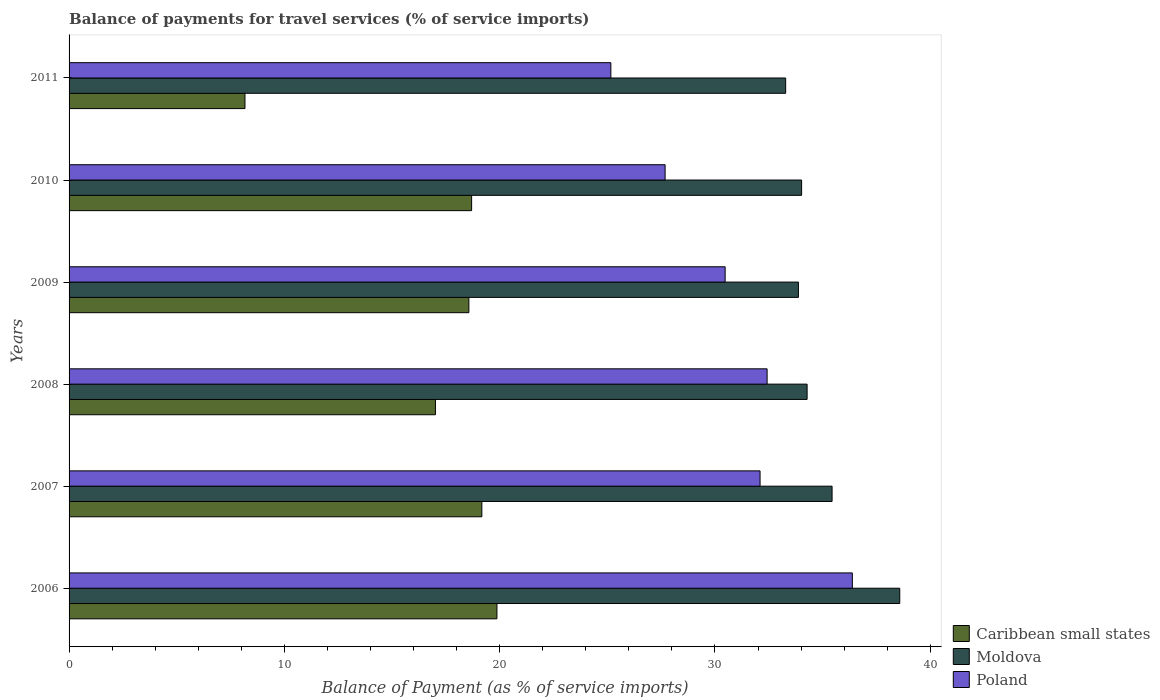How many different coloured bars are there?
Your answer should be compact. 3. How many groups of bars are there?
Offer a very short reply. 6. Are the number of bars per tick equal to the number of legend labels?
Keep it short and to the point. Yes. What is the balance of payments for travel services in Caribbean small states in 2006?
Your response must be concise. 19.87. Across all years, what is the maximum balance of payments for travel services in Caribbean small states?
Provide a succinct answer. 19.87. Across all years, what is the minimum balance of payments for travel services in Moldova?
Give a very brief answer. 33.28. In which year was the balance of payments for travel services in Poland maximum?
Your answer should be very brief. 2006. What is the total balance of payments for travel services in Moldova in the graph?
Give a very brief answer. 209.49. What is the difference between the balance of payments for travel services in Caribbean small states in 2007 and that in 2011?
Ensure brevity in your answer.  11. What is the difference between the balance of payments for travel services in Poland in 2010 and the balance of payments for travel services in Moldova in 2009?
Ensure brevity in your answer.  -6.19. What is the average balance of payments for travel services in Caribbean small states per year?
Provide a short and direct response. 16.92. In the year 2008, what is the difference between the balance of payments for travel services in Poland and balance of payments for travel services in Caribbean small states?
Your answer should be very brief. 15.41. In how many years, is the balance of payments for travel services in Caribbean small states greater than 18 %?
Keep it short and to the point. 4. What is the ratio of the balance of payments for travel services in Caribbean small states in 2006 to that in 2010?
Keep it short and to the point. 1.06. Is the balance of payments for travel services in Moldova in 2008 less than that in 2010?
Your response must be concise. No. Is the difference between the balance of payments for travel services in Poland in 2009 and 2011 greater than the difference between the balance of payments for travel services in Caribbean small states in 2009 and 2011?
Make the answer very short. No. What is the difference between the highest and the second highest balance of payments for travel services in Moldova?
Keep it short and to the point. 3.14. What is the difference between the highest and the lowest balance of payments for travel services in Poland?
Ensure brevity in your answer.  11.22. In how many years, is the balance of payments for travel services in Moldova greater than the average balance of payments for travel services in Moldova taken over all years?
Your answer should be compact. 2. Is the sum of the balance of payments for travel services in Moldova in 2008 and 2010 greater than the maximum balance of payments for travel services in Caribbean small states across all years?
Keep it short and to the point. Yes. What does the 1st bar from the top in 2010 represents?
Offer a very short reply. Poland. What does the 1st bar from the bottom in 2009 represents?
Give a very brief answer. Caribbean small states. How many bars are there?
Ensure brevity in your answer.  18. Are all the bars in the graph horizontal?
Provide a succinct answer. Yes. How many years are there in the graph?
Offer a very short reply. 6. What is the difference between two consecutive major ticks on the X-axis?
Your response must be concise. 10. Does the graph contain grids?
Make the answer very short. No. Where does the legend appear in the graph?
Provide a succinct answer. Bottom right. How many legend labels are there?
Provide a succinct answer. 3. How are the legend labels stacked?
Give a very brief answer. Vertical. What is the title of the graph?
Provide a short and direct response. Balance of payments for travel services (% of service imports). Does "Lithuania" appear as one of the legend labels in the graph?
Your answer should be very brief. No. What is the label or title of the X-axis?
Your response must be concise. Balance of Payment (as % of service imports). What is the Balance of Payment (as % of service imports) in Caribbean small states in 2006?
Provide a succinct answer. 19.87. What is the Balance of Payment (as % of service imports) of Moldova in 2006?
Provide a succinct answer. 38.58. What is the Balance of Payment (as % of service imports) of Poland in 2006?
Your response must be concise. 36.38. What is the Balance of Payment (as % of service imports) in Caribbean small states in 2007?
Make the answer very short. 19.17. What is the Balance of Payment (as % of service imports) of Moldova in 2007?
Offer a very short reply. 35.44. What is the Balance of Payment (as % of service imports) in Poland in 2007?
Offer a terse response. 32.1. What is the Balance of Payment (as % of service imports) in Caribbean small states in 2008?
Your answer should be compact. 17.02. What is the Balance of Payment (as % of service imports) in Moldova in 2008?
Your answer should be compact. 34.28. What is the Balance of Payment (as % of service imports) of Poland in 2008?
Your answer should be compact. 32.42. What is the Balance of Payment (as % of service imports) of Caribbean small states in 2009?
Provide a short and direct response. 18.57. What is the Balance of Payment (as % of service imports) of Moldova in 2009?
Make the answer very short. 33.88. What is the Balance of Payment (as % of service imports) in Poland in 2009?
Offer a terse response. 30.47. What is the Balance of Payment (as % of service imports) in Caribbean small states in 2010?
Ensure brevity in your answer.  18.7. What is the Balance of Payment (as % of service imports) of Moldova in 2010?
Offer a terse response. 34.03. What is the Balance of Payment (as % of service imports) in Poland in 2010?
Your answer should be very brief. 27.69. What is the Balance of Payment (as % of service imports) of Caribbean small states in 2011?
Make the answer very short. 8.17. What is the Balance of Payment (as % of service imports) in Moldova in 2011?
Offer a very short reply. 33.28. What is the Balance of Payment (as % of service imports) in Poland in 2011?
Ensure brevity in your answer.  25.17. Across all years, what is the maximum Balance of Payment (as % of service imports) of Caribbean small states?
Provide a short and direct response. 19.87. Across all years, what is the maximum Balance of Payment (as % of service imports) of Moldova?
Your response must be concise. 38.58. Across all years, what is the maximum Balance of Payment (as % of service imports) of Poland?
Give a very brief answer. 36.38. Across all years, what is the minimum Balance of Payment (as % of service imports) of Caribbean small states?
Provide a short and direct response. 8.17. Across all years, what is the minimum Balance of Payment (as % of service imports) of Moldova?
Give a very brief answer. 33.28. Across all years, what is the minimum Balance of Payment (as % of service imports) in Poland?
Make the answer very short. 25.17. What is the total Balance of Payment (as % of service imports) in Caribbean small states in the graph?
Provide a succinct answer. 101.5. What is the total Balance of Payment (as % of service imports) in Moldova in the graph?
Keep it short and to the point. 209.49. What is the total Balance of Payment (as % of service imports) of Poland in the graph?
Give a very brief answer. 184.23. What is the difference between the Balance of Payment (as % of service imports) of Caribbean small states in 2006 and that in 2007?
Provide a succinct answer. 0.7. What is the difference between the Balance of Payment (as % of service imports) in Moldova in 2006 and that in 2007?
Ensure brevity in your answer.  3.14. What is the difference between the Balance of Payment (as % of service imports) of Poland in 2006 and that in 2007?
Ensure brevity in your answer.  4.29. What is the difference between the Balance of Payment (as % of service imports) of Caribbean small states in 2006 and that in 2008?
Your response must be concise. 2.86. What is the difference between the Balance of Payment (as % of service imports) of Moldova in 2006 and that in 2008?
Your answer should be compact. 4.3. What is the difference between the Balance of Payment (as % of service imports) of Poland in 2006 and that in 2008?
Ensure brevity in your answer.  3.96. What is the difference between the Balance of Payment (as % of service imports) in Caribbean small states in 2006 and that in 2009?
Your answer should be very brief. 1.3. What is the difference between the Balance of Payment (as % of service imports) of Moldova in 2006 and that in 2009?
Your answer should be compact. 4.71. What is the difference between the Balance of Payment (as % of service imports) in Poland in 2006 and that in 2009?
Your answer should be very brief. 5.91. What is the difference between the Balance of Payment (as % of service imports) of Caribbean small states in 2006 and that in 2010?
Make the answer very short. 1.18. What is the difference between the Balance of Payment (as % of service imports) of Moldova in 2006 and that in 2010?
Offer a very short reply. 4.56. What is the difference between the Balance of Payment (as % of service imports) of Poland in 2006 and that in 2010?
Your response must be concise. 8.7. What is the difference between the Balance of Payment (as % of service imports) in Caribbean small states in 2006 and that in 2011?
Offer a terse response. 11.7. What is the difference between the Balance of Payment (as % of service imports) in Moldova in 2006 and that in 2011?
Your response must be concise. 5.3. What is the difference between the Balance of Payment (as % of service imports) of Poland in 2006 and that in 2011?
Give a very brief answer. 11.22. What is the difference between the Balance of Payment (as % of service imports) in Caribbean small states in 2007 and that in 2008?
Offer a terse response. 2.16. What is the difference between the Balance of Payment (as % of service imports) in Moldova in 2007 and that in 2008?
Provide a short and direct response. 1.16. What is the difference between the Balance of Payment (as % of service imports) in Poland in 2007 and that in 2008?
Offer a terse response. -0.33. What is the difference between the Balance of Payment (as % of service imports) of Caribbean small states in 2007 and that in 2009?
Make the answer very short. 0.6. What is the difference between the Balance of Payment (as % of service imports) of Moldova in 2007 and that in 2009?
Your answer should be compact. 1.56. What is the difference between the Balance of Payment (as % of service imports) in Poland in 2007 and that in 2009?
Provide a short and direct response. 1.62. What is the difference between the Balance of Payment (as % of service imports) in Caribbean small states in 2007 and that in 2010?
Make the answer very short. 0.47. What is the difference between the Balance of Payment (as % of service imports) in Moldova in 2007 and that in 2010?
Provide a succinct answer. 1.42. What is the difference between the Balance of Payment (as % of service imports) in Poland in 2007 and that in 2010?
Offer a terse response. 4.41. What is the difference between the Balance of Payment (as % of service imports) of Caribbean small states in 2007 and that in 2011?
Ensure brevity in your answer.  11. What is the difference between the Balance of Payment (as % of service imports) of Moldova in 2007 and that in 2011?
Make the answer very short. 2.16. What is the difference between the Balance of Payment (as % of service imports) in Poland in 2007 and that in 2011?
Your answer should be very brief. 6.93. What is the difference between the Balance of Payment (as % of service imports) in Caribbean small states in 2008 and that in 2009?
Your answer should be compact. -1.55. What is the difference between the Balance of Payment (as % of service imports) of Moldova in 2008 and that in 2009?
Offer a terse response. 0.4. What is the difference between the Balance of Payment (as % of service imports) of Poland in 2008 and that in 2009?
Your answer should be compact. 1.95. What is the difference between the Balance of Payment (as % of service imports) of Caribbean small states in 2008 and that in 2010?
Offer a terse response. -1.68. What is the difference between the Balance of Payment (as % of service imports) in Moldova in 2008 and that in 2010?
Provide a short and direct response. 0.26. What is the difference between the Balance of Payment (as % of service imports) of Poland in 2008 and that in 2010?
Your response must be concise. 4.74. What is the difference between the Balance of Payment (as % of service imports) of Caribbean small states in 2008 and that in 2011?
Provide a succinct answer. 8.85. What is the difference between the Balance of Payment (as % of service imports) in Moldova in 2008 and that in 2011?
Offer a very short reply. 1. What is the difference between the Balance of Payment (as % of service imports) of Poland in 2008 and that in 2011?
Your answer should be very brief. 7.26. What is the difference between the Balance of Payment (as % of service imports) in Caribbean small states in 2009 and that in 2010?
Your answer should be compact. -0.13. What is the difference between the Balance of Payment (as % of service imports) in Moldova in 2009 and that in 2010?
Ensure brevity in your answer.  -0.15. What is the difference between the Balance of Payment (as % of service imports) in Poland in 2009 and that in 2010?
Offer a very short reply. 2.79. What is the difference between the Balance of Payment (as % of service imports) of Caribbean small states in 2009 and that in 2011?
Provide a short and direct response. 10.4. What is the difference between the Balance of Payment (as % of service imports) in Moldova in 2009 and that in 2011?
Provide a short and direct response. 0.59. What is the difference between the Balance of Payment (as % of service imports) of Poland in 2009 and that in 2011?
Make the answer very short. 5.31. What is the difference between the Balance of Payment (as % of service imports) of Caribbean small states in 2010 and that in 2011?
Your response must be concise. 10.53. What is the difference between the Balance of Payment (as % of service imports) of Moldova in 2010 and that in 2011?
Offer a very short reply. 0.74. What is the difference between the Balance of Payment (as % of service imports) in Poland in 2010 and that in 2011?
Offer a very short reply. 2.52. What is the difference between the Balance of Payment (as % of service imports) of Caribbean small states in 2006 and the Balance of Payment (as % of service imports) of Moldova in 2007?
Your answer should be very brief. -15.57. What is the difference between the Balance of Payment (as % of service imports) of Caribbean small states in 2006 and the Balance of Payment (as % of service imports) of Poland in 2007?
Ensure brevity in your answer.  -12.22. What is the difference between the Balance of Payment (as % of service imports) of Moldova in 2006 and the Balance of Payment (as % of service imports) of Poland in 2007?
Provide a succinct answer. 6.49. What is the difference between the Balance of Payment (as % of service imports) of Caribbean small states in 2006 and the Balance of Payment (as % of service imports) of Moldova in 2008?
Offer a very short reply. -14.41. What is the difference between the Balance of Payment (as % of service imports) of Caribbean small states in 2006 and the Balance of Payment (as % of service imports) of Poland in 2008?
Offer a terse response. -12.55. What is the difference between the Balance of Payment (as % of service imports) of Moldova in 2006 and the Balance of Payment (as % of service imports) of Poland in 2008?
Your response must be concise. 6.16. What is the difference between the Balance of Payment (as % of service imports) of Caribbean small states in 2006 and the Balance of Payment (as % of service imports) of Moldova in 2009?
Keep it short and to the point. -14. What is the difference between the Balance of Payment (as % of service imports) in Caribbean small states in 2006 and the Balance of Payment (as % of service imports) in Poland in 2009?
Ensure brevity in your answer.  -10.6. What is the difference between the Balance of Payment (as % of service imports) in Moldova in 2006 and the Balance of Payment (as % of service imports) in Poland in 2009?
Offer a very short reply. 8.11. What is the difference between the Balance of Payment (as % of service imports) of Caribbean small states in 2006 and the Balance of Payment (as % of service imports) of Moldova in 2010?
Your answer should be compact. -14.15. What is the difference between the Balance of Payment (as % of service imports) of Caribbean small states in 2006 and the Balance of Payment (as % of service imports) of Poland in 2010?
Provide a short and direct response. -7.81. What is the difference between the Balance of Payment (as % of service imports) in Moldova in 2006 and the Balance of Payment (as % of service imports) in Poland in 2010?
Your answer should be very brief. 10.9. What is the difference between the Balance of Payment (as % of service imports) in Caribbean small states in 2006 and the Balance of Payment (as % of service imports) in Moldova in 2011?
Your response must be concise. -13.41. What is the difference between the Balance of Payment (as % of service imports) in Caribbean small states in 2006 and the Balance of Payment (as % of service imports) in Poland in 2011?
Provide a succinct answer. -5.29. What is the difference between the Balance of Payment (as % of service imports) in Moldova in 2006 and the Balance of Payment (as % of service imports) in Poland in 2011?
Give a very brief answer. 13.42. What is the difference between the Balance of Payment (as % of service imports) of Caribbean small states in 2007 and the Balance of Payment (as % of service imports) of Moldova in 2008?
Give a very brief answer. -15.11. What is the difference between the Balance of Payment (as % of service imports) of Caribbean small states in 2007 and the Balance of Payment (as % of service imports) of Poland in 2008?
Offer a terse response. -13.25. What is the difference between the Balance of Payment (as % of service imports) in Moldova in 2007 and the Balance of Payment (as % of service imports) in Poland in 2008?
Your answer should be very brief. 3.02. What is the difference between the Balance of Payment (as % of service imports) in Caribbean small states in 2007 and the Balance of Payment (as % of service imports) in Moldova in 2009?
Your answer should be compact. -14.7. What is the difference between the Balance of Payment (as % of service imports) of Caribbean small states in 2007 and the Balance of Payment (as % of service imports) of Poland in 2009?
Provide a succinct answer. -11.3. What is the difference between the Balance of Payment (as % of service imports) in Moldova in 2007 and the Balance of Payment (as % of service imports) in Poland in 2009?
Provide a succinct answer. 4.97. What is the difference between the Balance of Payment (as % of service imports) in Caribbean small states in 2007 and the Balance of Payment (as % of service imports) in Moldova in 2010?
Offer a very short reply. -14.85. What is the difference between the Balance of Payment (as % of service imports) in Caribbean small states in 2007 and the Balance of Payment (as % of service imports) in Poland in 2010?
Your answer should be very brief. -8.51. What is the difference between the Balance of Payment (as % of service imports) of Moldova in 2007 and the Balance of Payment (as % of service imports) of Poland in 2010?
Offer a terse response. 7.76. What is the difference between the Balance of Payment (as % of service imports) of Caribbean small states in 2007 and the Balance of Payment (as % of service imports) of Moldova in 2011?
Your answer should be compact. -14.11. What is the difference between the Balance of Payment (as % of service imports) of Caribbean small states in 2007 and the Balance of Payment (as % of service imports) of Poland in 2011?
Your answer should be compact. -5.99. What is the difference between the Balance of Payment (as % of service imports) in Moldova in 2007 and the Balance of Payment (as % of service imports) in Poland in 2011?
Give a very brief answer. 10.27. What is the difference between the Balance of Payment (as % of service imports) in Caribbean small states in 2008 and the Balance of Payment (as % of service imports) in Moldova in 2009?
Give a very brief answer. -16.86. What is the difference between the Balance of Payment (as % of service imports) in Caribbean small states in 2008 and the Balance of Payment (as % of service imports) in Poland in 2009?
Your response must be concise. -13.46. What is the difference between the Balance of Payment (as % of service imports) in Moldova in 2008 and the Balance of Payment (as % of service imports) in Poland in 2009?
Ensure brevity in your answer.  3.81. What is the difference between the Balance of Payment (as % of service imports) of Caribbean small states in 2008 and the Balance of Payment (as % of service imports) of Moldova in 2010?
Keep it short and to the point. -17.01. What is the difference between the Balance of Payment (as % of service imports) in Caribbean small states in 2008 and the Balance of Payment (as % of service imports) in Poland in 2010?
Give a very brief answer. -10.67. What is the difference between the Balance of Payment (as % of service imports) of Moldova in 2008 and the Balance of Payment (as % of service imports) of Poland in 2010?
Your response must be concise. 6.6. What is the difference between the Balance of Payment (as % of service imports) in Caribbean small states in 2008 and the Balance of Payment (as % of service imports) in Moldova in 2011?
Offer a very short reply. -16.27. What is the difference between the Balance of Payment (as % of service imports) of Caribbean small states in 2008 and the Balance of Payment (as % of service imports) of Poland in 2011?
Ensure brevity in your answer.  -8.15. What is the difference between the Balance of Payment (as % of service imports) of Moldova in 2008 and the Balance of Payment (as % of service imports) of Poland in 2011?
Give a very brief answer. 9.12. What is the difference between the Balance of Payment (as % of service imports) of Caribbean small states in 2009 and the Balance of Payment (as % of service imports) of Moldova in 2010?
Provide a short and direct response. -15.46. What is the difference between the Balance of Payment (as % of service imports) of Caribbean small states in 2009 and the Balance of Payment (as % of service imports) of Poland in 2010?
Provide a short and direct response. -9.12. What is the difference between the Balance of Payment (as % of service imports) in Moldova in 2009 and the Balance of Payment (as % of service imports) in Poland in 2010?
Your response must be concise. 6.19. What is the difference between the Balance of Payment (as % of service imports) in Caribbean small states in 2009 and the Balance of Payment (as % of service imports) in Moldova in 2011?
Your answer should be very brief. -14.71. What is the difference between the Balance of Payment (as % of service imports) of Caribbean small states in 2009 and the Balance of Payment (as % of service imports) of Poland in 2011?
Keep it short and to the point. -6.6. What is the difference between the Balance of Payment (as % of service imports) in Moldova in 2009 and the Balance of Payment (as % of service imports) in Poland in 2011?
Offer a terse response. 8.71. What is the difference between the Balance of Payment (as % of service imports) of Caribbean small states in 2010 and the Balance of Payment (as % of service imports) of Moldova in 2011?
Make the answer very short. -14.59. What is the difference between the Balance of Payment (as % of service imports) of Caribbean small states in 2010 and the Balance of Payment (as % of service imports) of Poland in 2011?
Provide a succinct answer. -6.47. What is the difference between the Balance of Payment (as % of service imports) in Moldova in 2010 and the Balance of Payment (as % of service imports) in Poland in 2011?
Offer a terse response. 8.86. What is the average Balance of Payment (as % of service imports) in Caribbean small states per year?
Ensure brevity in your answer.  16.92. What is the average Balance of Payment (as % of service imports) of Moldova per year?
Keep it short and to the point. 34.92. What is the average Balance of Payment (as % of service imports) in Poland per year?
Keep it short and to the point. 30.7. In the year 2006, what is the difference between the Balance of Payment (as % of service imports) in Caribbean small states and Balance of Payment (as % of service imports) in Moldova?
Your response must be concise. -18.71. In the year 2006, what is the difference between the Balance of Payment (as % of service imports) of Caribbean small states and Balance of Payment (as % of service imports) of Poland?
Offer a very short reply. -16.51. In the year 2006, what is the difference between the Balance of Payment (as % of service imports) of Moldova and Balance of Payment (as % of service imports) of Poland?
Keep it short and to the point. 2.2. In the year 2007, what is the difference between the Balance of Payment (as % of service imports) in Caribbean small states and Balance of Payment (as % of service imports) in Moldova?
Offer a very short reply. -16.27. In the year 2007, what is the difference between the Balance of Payment (as % of service imports) in Caribbean small states and Balance of Payment (as % of service imports) in Poland?
Your answer should be very brief. -12.92. In the year 2007, what is the difference between the Balance of Payment (as % of service imports) of Moldova and Balance of Payment (as % of service imports) of Poland?
Your answer should be compact. 3.35. In the year 2008, what is the difference between the Balance of Payment (as % of service imports) in Caribbean small states and Balance of Payment (as % of service imports) in Moldova?
Ensure brevity in your answer.  -17.26. In the year 2008, what is the difference between the Balance of Payment (as % of service imports) of Caribbean small states and Balance of Payment (as % of service imports) of Poland?
Make the answer very short. -15.41. In the year 2008, what is the difference between the Balance of Payment (as % of service imports) in Moldova and Balance of Payment (as % of service imports) in Poland?
Provide a succinct answer. 1.86. In the year 2009, what is the difference between the Balance of Payment (as % of service imports) in Caribbean small states and Balance of Payment (as % of service imports) in Moldova?
Make the answer very short. -15.31. In the year 2009, what is the difference between the Balance of Payment (as % of service imports) in Caribbean small states and Balance of Payment (as % of service imports) in Poland?
Provide a short and direct response. -11.9. In the year 2009, what is the difference between the Balance of Payment (as % of service imports) of Moldova and Balance of Payment (as % of service imports) of Poland?
Keep it short and to the point. 3.4. In the year 2010, what is the difference between the Balance of Payment (as % of service imports) of Caribbean small states and Balance of Payment (as % of service imports) of Moldova?
Give a very brief answer. -15.33. In the year 2010, what is the difference between the Balance of Payment (as % of service imports) in Caribbean small states and Balance of Payment (as % of service imports) in Poland?
Your response must be concise. -8.99. In the year 2010, what is the difference between the Balance of Payment (as % of service imports) of Moldova and Balance of Payment (as % of service imports) of Poland?
Your response must be concise. 6.34. In the year 2011, what is the difference between the Balance of Payment (as % of service imports) of Caribbean small states and Balance of Payment (as % of service imports) of Moldova?
Provide a short and direct response. -25.11. In the year 2011, what is the difference between the Balance of Payment (as % of service imports) of Caribbean small states and Balance of Payment (as % of service imports) of Poland?
Offer a terse response. -17. In the year 2011, what is the difference between the Balance of Payment (as % of service imports) in Moldova and Balance of Payment (as % of service imports) in Poland?
Your response must be concise. 8.12. What is the ratio of the Balance of Payment (as % of service imports) in Caribbean small states in 2006 to that in 2007?
Give a very brief answer. 1.04. What is the ratio of the Balance of Payment (as % of service imports) in Moldova in 2006 to that in 2007?
Your answer should be very brief. 1.09. What is the ratio of the Balance of Payment (as % of service imports) in Poland in 2006 to that in 2007?
Ensure brevity in your answer.  1.13. What is the ratio of the Balance of Payment (as % of service imports) in Caribbean small states in 2006 to that in 2008?
Offer a very short reply. 1.17. What is the ratio of the Balance of Payment (as % of service imports) in Moldova in 2006 to that in 2008?
Offer a terse response. 1.13. What is the ratio of the Balance of Payment (as % of service imports) of Poland in 2006 to that in 2008?
Give a very brief answer. 1.12. What is the ratio of the Balance of Payment (as % of service imports) of Caribbean small states in 2006 to that in 2009?
Provide a succinct answer. 1.07. What is the ratio of the Balance of Payment (as % of service imports) of Moldova in 2006 to that in 2009?
Keep it short and to the point. 1.14. What is the ratio of the Balance of Payment (as % of service imports) in Poland in 2006 to that in 2009?
Your answer should be very brief. 1.19. What is the ratio of the Balance of Payment (as % of service imports) of Caribbean small states in 2006 to that in 2010?
Give a very brief answer. 1.06. What is the ratio of the Balance of Payment (as % of service imports) in Moldova in 2006 to that in 2010?
Your answer should be compact. 1.13. What is the ratio of the Balance of Payment (as % of service imports) in Poland in 2006 to that in 2010?
Make the answer very short. 1.31. What is the ratio of the Balance of Payment (as % of service imports) in Caribbean small states in 2006 to that in 2011?
Your response must be concise. 2.43. What is the ratio of the Balance of Payment (as % of service imports) in Moldova in 2006 to that in 2011?
Offer a very short reply. 1.16. What is the ratio of the Balance of Payment (as % of service imports) in Poland in 2006 to that in 2011?
Your answer should be compact. 1.45. What is the ratio of the Balance of Payment (as % of service imports) in Caribbean small states in 2007 to that in 2008?
Offer a terse response. 1.13. What is the ratio of the Balance of Payment (as % of service imports) of Moldova in 2007 to that in 2008?
Offer a terse response. 1.03. What is the ratio of the Balance of Payment (as % of service imports) of Caribbean small states in 2007 to that in 2009?
Your response must be concise. 1.03. What is the ratio of the Balance of Payment (as % of service imports) of Moldova in 2007 to that in 2009?
Ensure brevity in your answer.  1.05. What is the ratio of the Balance of Payment (as % of service imports) of Poland in 2007 to that in 2009?
Ensure brevity in your answer.  1.05. What is the ratio of the Balance of Payment (as % of service imports) in Caribbean small states in 2007 to that in 2010?
Your response must be concise. 1.03. What is the ratio of the Balance of Payment (as % of service imports) of Moldova in 2007 to that in 2010?
Give a very brief answer. 1.04. What is the ratio of the Balance of Payment (as % of service imports) of Poland in 2007 to that in 2010?
Your response must be concise. 1.16. What is the ratio of the Balance of Payment (as % of service imports) of Caribbean small states in 2007 to that in 2011?
Your response must be concise. 2.35. What is the ratio of the Balance of Payment (as % of service imports) of Moldova in 2007 to that in 2011?
Offer a terse response. 1.06. What is the ratio of the Balance of Payment (as % of service imports) of Poland in 2007 to that in 2011?
Offer a terse response. 1.28. What is the ratio of the Balance of Payment (as % of service imports) of Caribbean small states in 2008 to that in 2009?
Keep it short and to the point. 0.92. What is the ratio of the Balance of Payment (as % of service imports) in Moldova in 2008 to that in 2009?
Your answer should be very brief. 1.01. What is the ratio of the Balance of Payment (as % of service imports) in Poland in 2008 to that in 2009?
Ensure brevity in your answer.  1.06. What is the ratio of the Balance of Payment (as % of service imports) in Caribbean small states in 2008 to that in 2010?
Offer a terse response. 0.91. What is the ratio of the Balance of Payment (as % of service imports) in Moldova in 2008 to that in 2010?
Offer a terse response. 1.01. What is the ratio of the Balance of Payment (as % of service imports) in Poland in 2008 to that in 2010?
Your answer should be very brief. 1.17. What is the ratio of the Balance of Payment (as % of service imports) of Caribbean small states in 2008 to that in 2011?
Provide a short and direct response. 2.08. What is the ratio of the Balance of Payment (as % of service imports) of Moldova in 2008 to that in 2011?
Offer a terse response. 1.03. What is the ratio of the Balance of Payment (as % of service imports) in Poland in 2008 to that in 2011?
Provide a short and direct response. 1.29. What is the ratio of the Balance of Payment (as % of service imports) in Caribbean small states in 2009 to that in 2010?
Keep it short and to the point. 0.99. What is the ratio of the Balance of Payment (as % of service imports) of Poland in 2009 to that in 2010?
Offer a terse response. 1.1. What is the ratio of the Balance of Payment (as % of service imports) of Caribbean small states in 2009 to that in 2011?
Your response must be concise. 2.27. What is the ratio of the Balance of Payment (as % of service imports) in Moldova in 2009 to that in 2011?
Your response must be concise. 1.02. What is the ratio of the Balance of Payment (as % of service imports) of Poland in 2009 to that in 2011?
Make the answer very short. 1.21. What is the ratio of the Balance of Payment (as % of service imports) of Caribbean small states in 2010 to that in 2011?
Your response must be concise. 2.29. What is the ratio of the Balance of Payment (as % of service imports) in Moldova in 2010 to that in 2011?
Provide a short and direct response. 1.02. What is the ratio of the Balance of Payment (as % of service imports) in Poland in 2010 to that in 2011?
Your answer should be compact. 1.1. What is the difference between the highest and the second highest Balance of Payment (as % of service imports) of Caribbean small states?
Ensure brevity in your answer.  0.7. What is the difference between the highest and the second highest Balance of Payment (as % of service imports) in Moldova?
Your response must be concise. 3.14. What is the difference between the highest and the second highest Balance of Payment (as % of service imports) of Poland?
Your answer should be very brief. 3.96. What is the difference between the highest and the lowest Balance of Payment (as % of service imports) of Caribbean small states?
Keep it short and to the point. 11.7. What is the difference between the highest and the lowest Balance of Payment (as % of service imports) in Poland?
Ensure brevity in your answer.  11.22. 